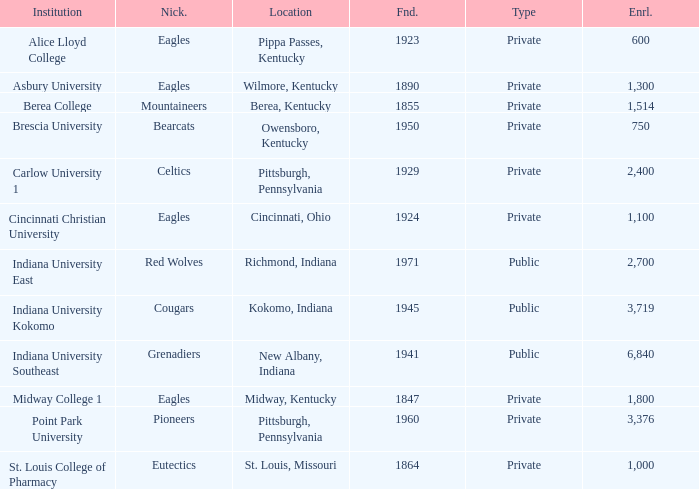Which public college has a nickname of The Grenadiers? Indiana University Southeast. 